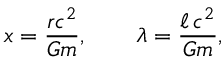<formula> <loc_0><loc_0><loc_500><loc_500>x = \frac { r c ^ { 2 } } { G m } , \quad \lambda = \frac { \ell \, c ^ { 2 } } { G m } ,</formula> 